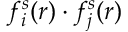<formula> <loc_0><loc_0><loc_500><loc_500>f _ { i } ^ { s } ( r ) \cdot f _ { j } ^ { s } ( r )</formula> 